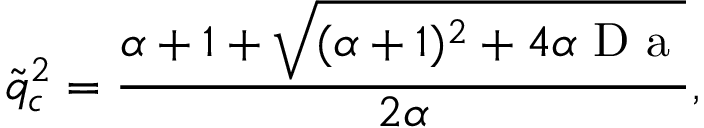<formula> <loc_0><loc_0><loc_500><loc_500>\tilde { q } _ { c } ^ { 2 } = \frac { \alpha + 1 + \sqrt { ( \alpha + 1 ) ^ { 2 } + 4 \alpha D a } } { 2 \alpha } ,</formula> 